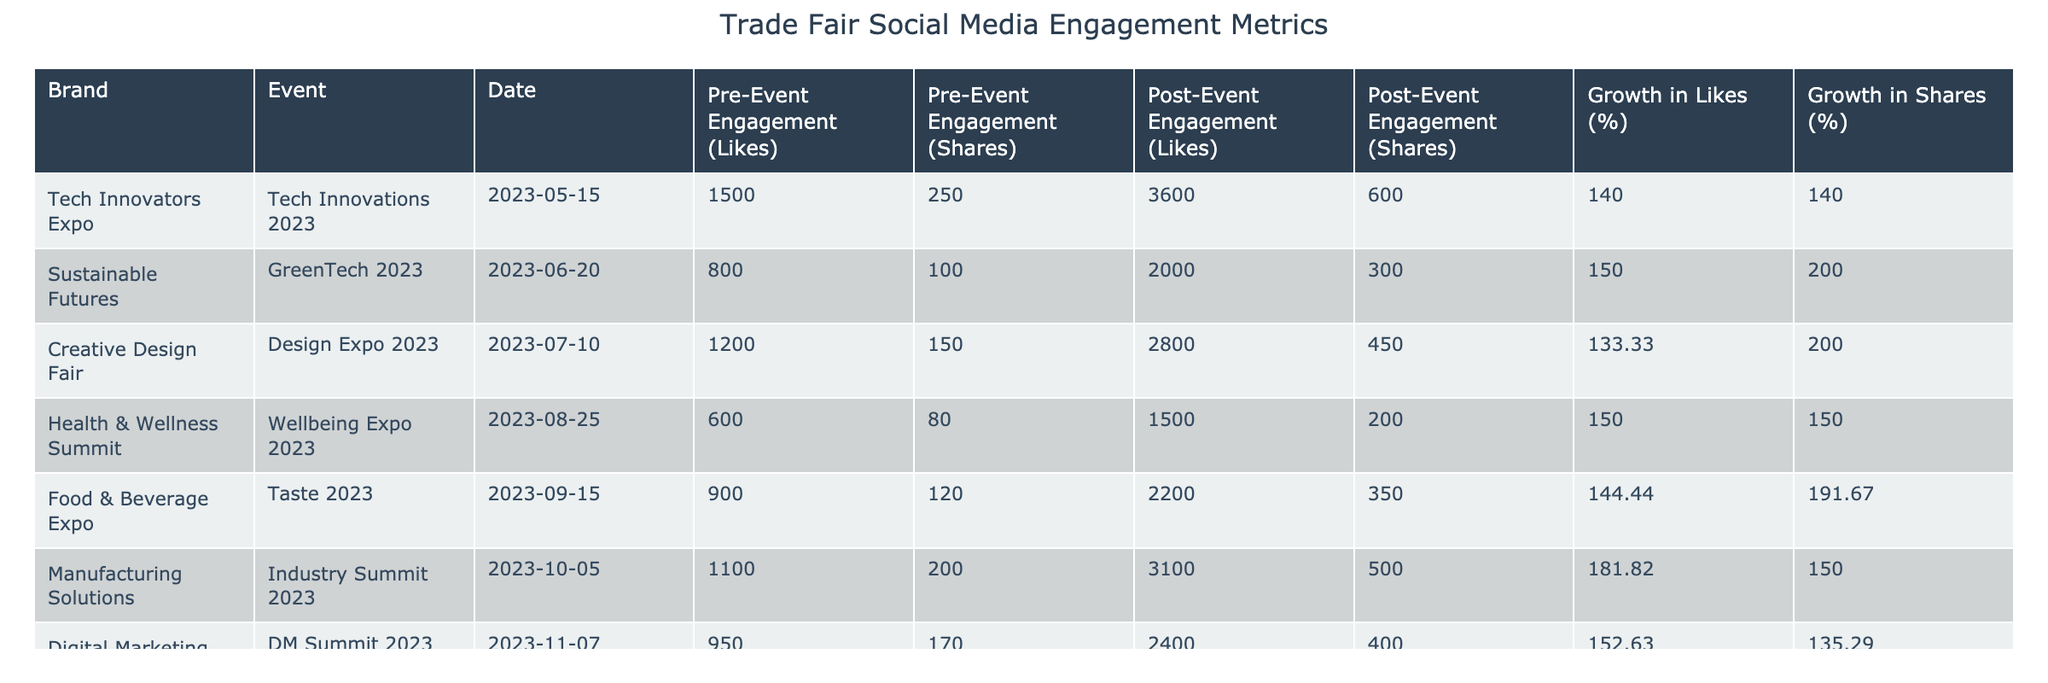What was the post-event engagement in likes for the Tech Innovators Expo? The table shows that the post-event engagement in likes for the Tech Innovators Expo is specified in the "Post-Event Engagement (Likes)" column. The value for this event is 3600.
Answer: 3600 What is the difference in pre-event shares between the Sustainable Futures and the Food & Beverage Expo? The pre-event shares for Sustainable Futures is 100, and for Food & Beverage Expo it is 120. The difference is calculated as 120 - 100 = 20.
Answer: 20 Did the Creative Design Fair have higher growth in likes than the Health & Wellness Summit? The growth in likes for the Creative Design Fair is 133.33%, while for the Health & Wellness Summit, it is 150%. Since 133.33% is less than 150%, the statement is false.
Answer: No Which event had the highest post-event engagement in shares? The post-event engagement in shares for all events is listed, and the maximum value is 600 from the Tech Innovators Expo, which is higher than the shares for other events.
Answer: Tech Innovators Expo What was the average growth in shares across all listed events? The growth in shares values are 140, 200, 200, 150, 191.67, 150, and 135.29. The average is calculated by summing these values (140 + 200 + 200 + 150 + 191.67 + 150 + 135.29 = 1167.96) and then dividing by the number of events (1167.96 / 7 ≈ 166.71).
Answer: 166.71 Has the Digital Marketing Conference shown a greater percentage growth in likes compared to the Food & Beverage Expo? The growth in likes for Digital Marketing Conference is 152.63%, and for Food & Beverage Expo, it is 144.44%. Since 152.63% is greater than 144.44%, the statement is true.
Answer: Yes What are the post-event engagement figures for the Health & Wellness Summit? The table indicates that for the Health & Wellness Summit, the post-event engagement figures are 1500 likes and 200 shares.
Answer: 1500 likes, 200 shares Which two brands had the highest percentage growth in shares? By reviewing the growth in shares for all brands, we see the Sustainable Futures and Food & Beverage Expo had growth of 200% and 191.67% respectively, which are the two highest percentages.
Answer: Sustainable Futures, Food & Beverage Expo What was the pre-event engagement in likes for the Digital Marketing Conference? The table lists pre-event engagement in likes for the Digital Marketing Conference as 950.
Answer: 950 